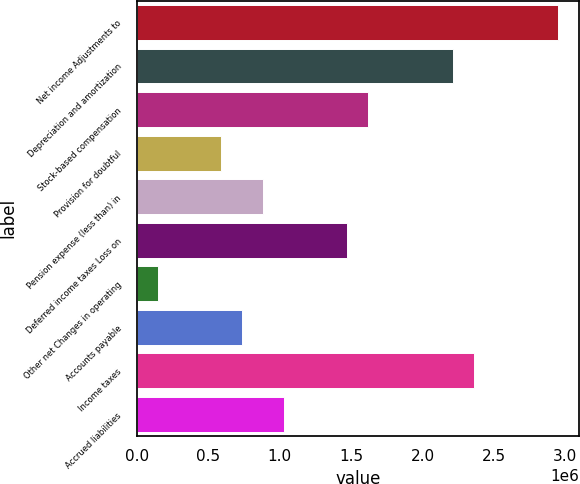Convert chart. <chart><loc_0><loc_0><loc_500><loc_500><bar_chart><fcel>Net income Adjustments to<fcel>Depreciation and amortization<fcel>Stock-based compensation<fcel>Provision for doubtful<fcel>Pension expense (less than) in<fcel>Deferred income taxes Loss on<fcel>Other net Changes in operating<fcel>Accounts payable<fcel>Income taxes<fcel>Accrued liabilities<nl><fcel>2.94845e+06<fcel>2.21156e+06<fcel>1.62204e+06<fcel>590386<fcel>885144<fcel>1.47466e+06<fcel>148249<fcel>737765<fcel>2.35893e+06<fcel>1.03252e+06<nl></chart> 